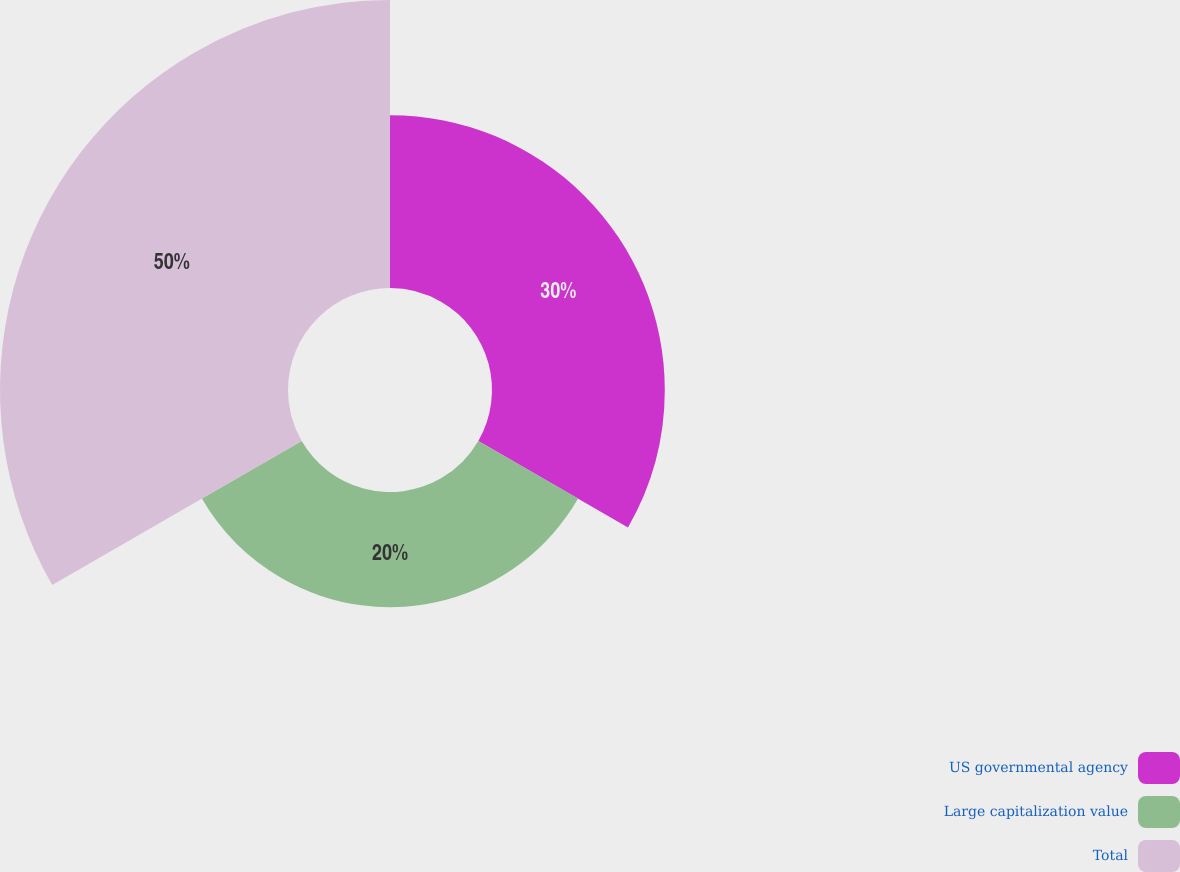Convert chart to OTSL. <chart><loc_0><loc_0><loc_500><loc_500><pie_chart><fcel>US governmental agency<fcel>Large capitalization value<fcel>Total<nl><fcel>30.0%<fcel>20.0%<fcel>50.0%<nl></chart> 